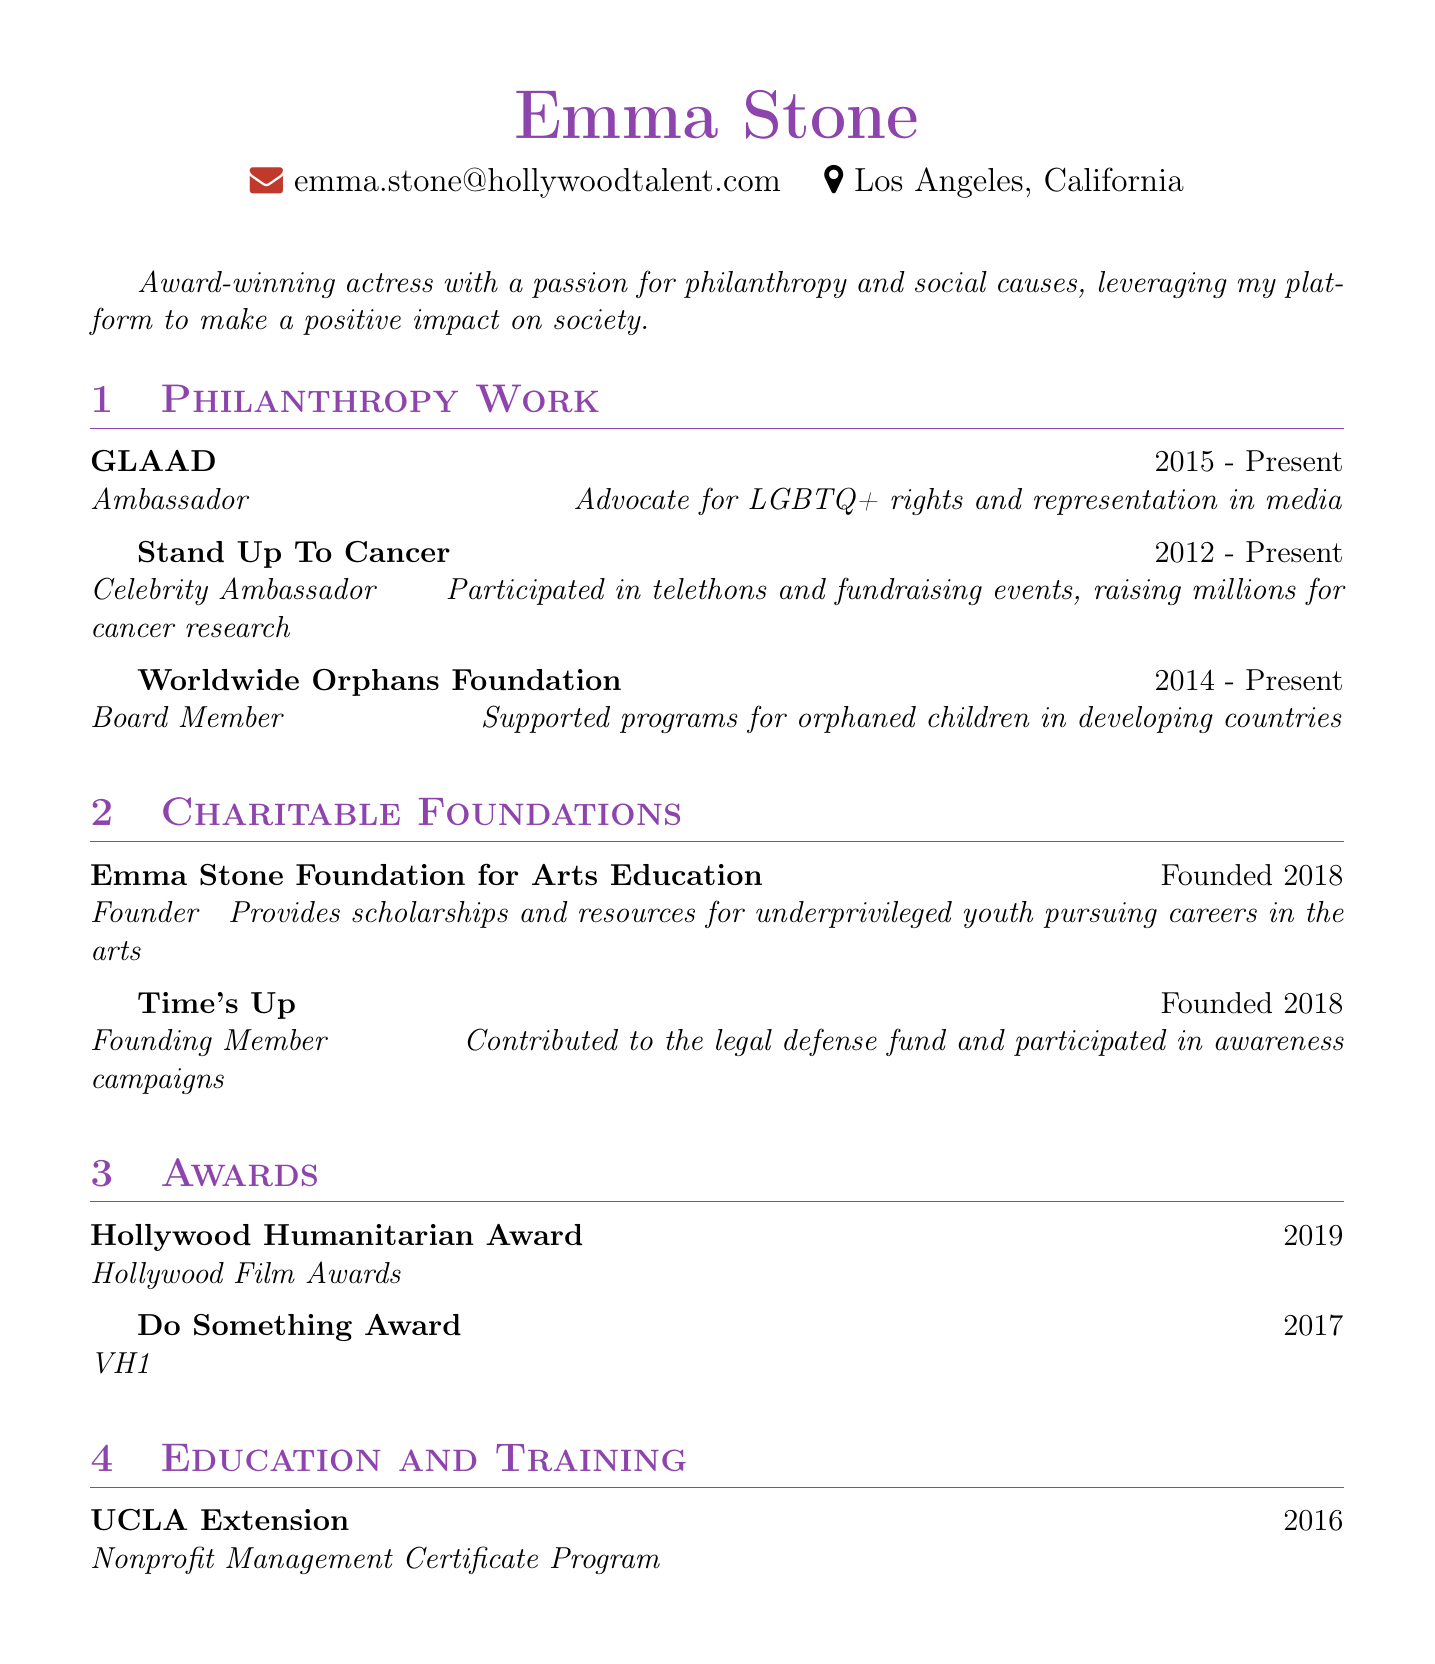What is the full name of the actress? The full name of the actress is mentioned at the beginning of the document.
Answer: Emma Stone What is Emma Stone's role at GLAAD? The document states her role at GLAAD as listed under philanthropy work.
Answer: Ambassador In what year did Emma Stone found her arts education foundation? The founding year is specified in the charitable foundations supported section of the document.
Answer: 2018 How long has Emma Stone been a Celebrity Ambassador for Stand Up To Cancer? The duration can be calculated from the starting year listed in the document until the present.
Answer: 11 years What award did Emma Stone receive in 2019? The award name is listed under the awards section of the document.
Answer: Hollywood Humanitarian Award Which nonprofit management program did Emma Stone complete? The specific course is mentioned under education and training in the document.
Answer: Nonprofit Management Certificate Program How many organizations does Emma Stone currently support as listed in the document? The total number of organizations is calculated from the philanthropy work and charitable foundations supported sections combined.
Answer: 5 What is the primary focus of the Emma Stone Foundation for Arts Education? The focus is derived from the description provided in the charitable foundations section.
Answer: Scholarships and resources for underprivileged youth What does Emma Stone do for Worldwide Orphans Foundation? Her role and activities are described in the philanthropy work section.
Answer: Board Member 